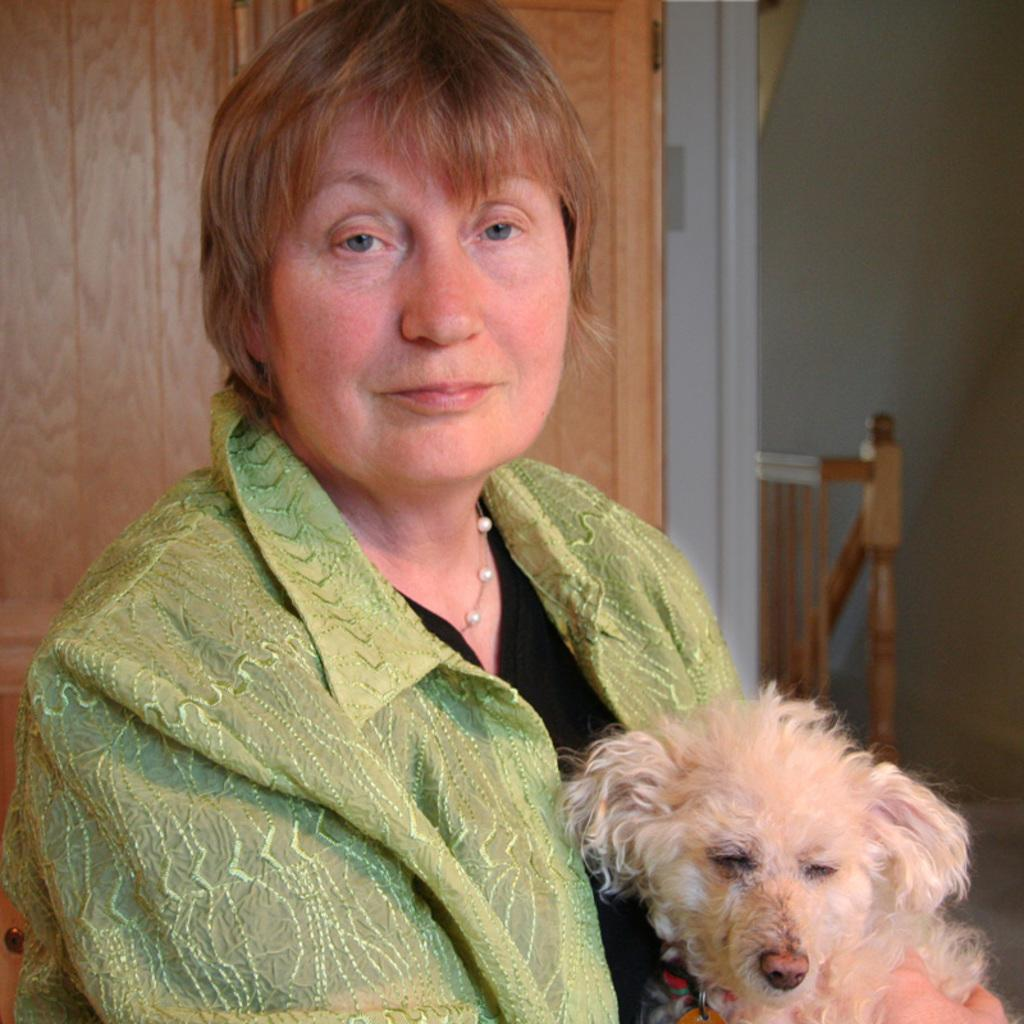Who is present in the image? There is a woman in the image. What is the woman wearing? The woman is wearing a green shirt. What is the woman holding in the image? The woman is holding a dog. What can be seen in the background of the image? There is a wooden door and a wall in the background of the image. What is the color of the wooden door and the wall? The wooden door and the wall are both white in color. Is there a chain attached to the dog in the image? There is no chain visible in the image; the woman is simply holding the dog. 